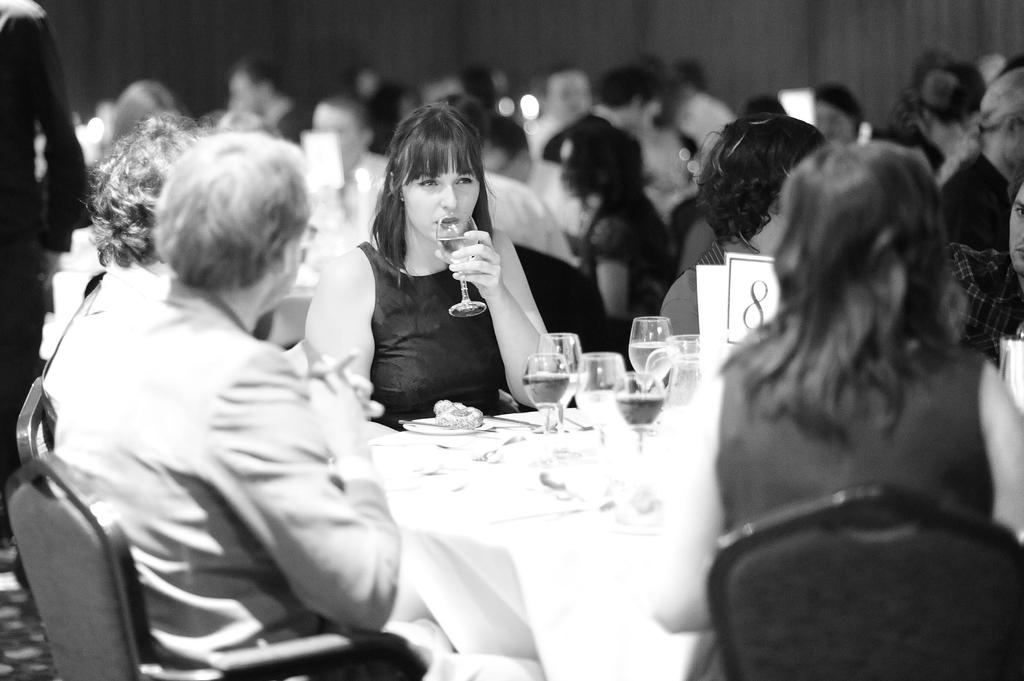How many people are in the image? There is a group of people in the image. What are the people doing in the image? The people are sitting around a table. What objects can be seen on the table? There are glasses on the table. Can you describe the action of one of the people in the image? One woman is drinking from a glass. What type of wall can be seen in the image? There is no wall present in the image; it features a group of people sitting around a table. 